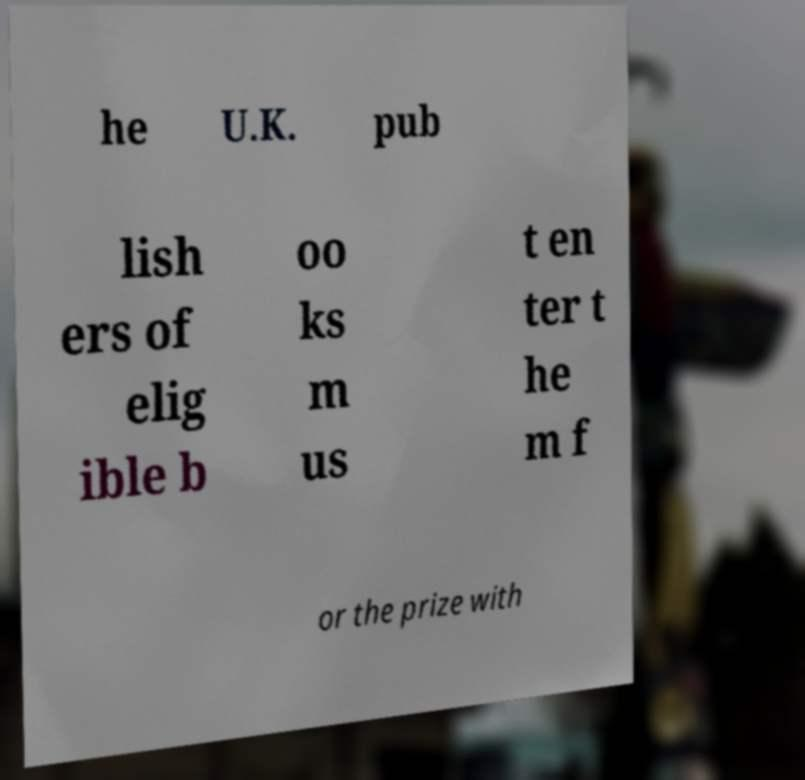I need the written content from this picture converted into text. Can you do that? he U.K. pub lish ers of elig ible b oo ks m us t en ter t he m f or the prize with 